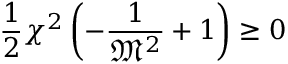Convert formula to latex. <formula><loc_0><loc_0><loc_500><loc_500>{ \frac { 1 } { 2 } } \chi ^ { 2 } \left ( - { \frac { 1 } { { \mathfrak { M } } ^ { 2 } } } + 1 \right ) \geq 0</formula> 